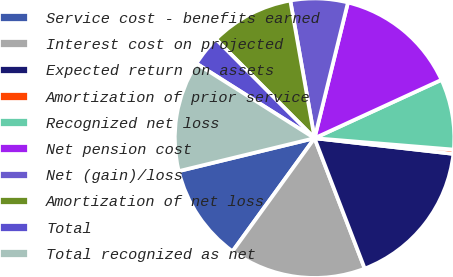<chart> <loc_0><loc_0><loc_500><loc_500><pie_chart><fcel>Service cost - benefits earned<fcel>Interest cost on projected<fcel>Expected return on assets<fcel>Amortization of prior service<fcel>Recognized net loss<fcel>Net pension cost<fcel>Net (gain)/loss<fcel>Amortization of net loss<fcel>Total<fcel>Total recognized as net<nl><fcel>11.23%<fcel>15.83%<fcel>17.36%<fcel>0.49%<fcel>8.16%<fcel>14.3%<fcel>6.62%<fcel>9.69%<fcel>3.56%<fcel>12.76%<nl></chart> 